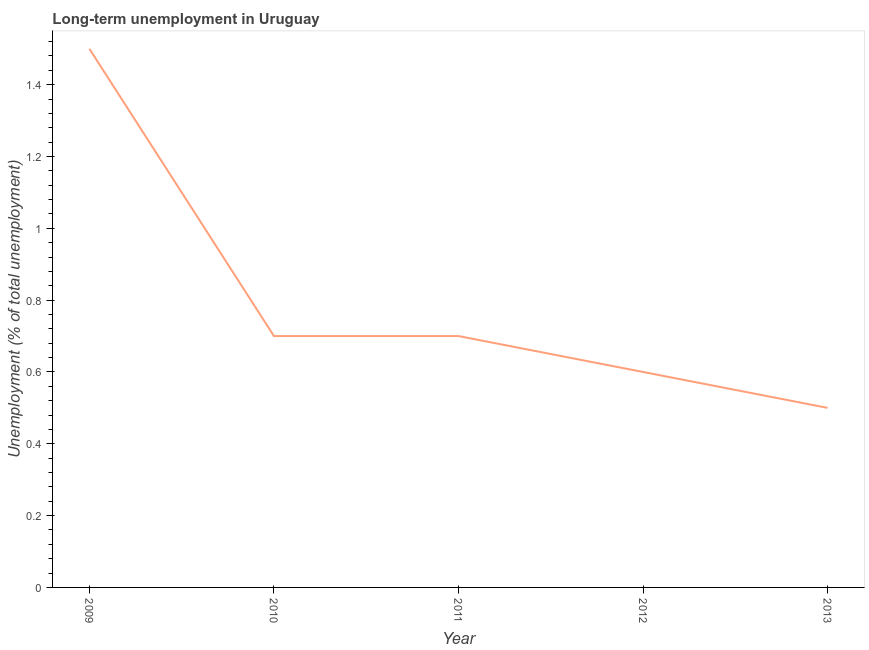What is the long-term unemployment in 2010?
Provide a succinct answer. 0.7. In which year was the long-term unemployment minimum?
Offer a very short reply. 2013. What is the sum of the long-term unemployment?
Give a very brief answer. 4. What is the difference between the long-term unemployment in 2010 and 2013?
Your response must be concise. 0.2. What is the median long-term unemployment?
Make the answer very short. 0.7. Do a majority of the years between 2013 and 2011 (inclusive) have long-term unemployment greater than 0.28 %?
Your answer should be very brief. No. What is the ratio of the long-term unemployment in 2009 to that in 2010?
Your response must be concise. 2.14. Is the difference between the long-term unemployment in 2009 and 2011 greater than the difference between any two years?
Your answer should be very brief. No. What is the difference between the highest and the second highest long-term unemployment?
Offer a terse response. 0.8. What is the difference between the highest and the lowest long-term unemployment?
Offer a terse response. 1. In how many years, is the long-term unemployment greater than the average long-term unemployment taken over all years?
Your answer should be very brief. 1. How many lines are there?
Your answer should be very brief. 1. How many years are there in the graph?
Provide a short and direct response. 5. What is the difference between two consecutive major ticks on the Y-axis?
Give a very brief answer. 0.2. What is the title of the graph?
Provide a short and direct response. Long-term unemployment in Uruguay. What is the label or title of the X-axis?
Your response must be concise. Year. What is the label or title of the Y-axis?
Ensure brevity in your answer.  Unemployment (% of total unemployment). What is the Unemployment (% of total unemployment) in 2010?
Keep it short and to the point. 0.7. What is the Unemployment (% of total unemployment) of 2011?
Your answer should be compact. 0.7. What is the Unemployment (% of total unemployment) in 2012?
Offer a terse response. 0.6. What is the difference between the Unemployment (% of total unemployment) in 2009 and 2012?
Offer a very short reply. 0.9. What is the difference between the Unemployment (% of total unemployment) in 2009 and 2013?
Give a very brief answer. 1. What is the difference between the Unemployment (% of total unemployment) in 2010 and 2013?
Your response must be concise. 0.2. What is the difference between the Unemployment (% of total unemployment) in 2012 and 2013?
Provide a short and direct response. 0.1. What is the ratio of the Unemployment (% of total unemployment) in 2009 to that in 2010?
Provide a succinct answer. 2.14. What is the ratio of the Unemployment (% of total unemployment) in 2009 to that in 2011?
Give a very brief answer. 2.14. What is the ratio of the Unemployment (% of total unemployment) in 2010 to that in 2011?
Ensure brevity in your answer.  1. What is the ratio of the Unemployment (% of total unemployment) in 2010 to that in 2012?
Your answer should be very brief. 1.17. What is the ratio of the Unemployment (% of total unemployment) in 2010 to that in 2013?
Your response must be concise. 1.4. What is the ratio of the Unemployment (% of total unemployment) in 2011 to that in 2012?
Provide a succinct answer. 1.17. What is the ratio of the Unemployment (% of total unemployment) in 2011 to that in 2013?
Give a very brief answer. 1.4. 